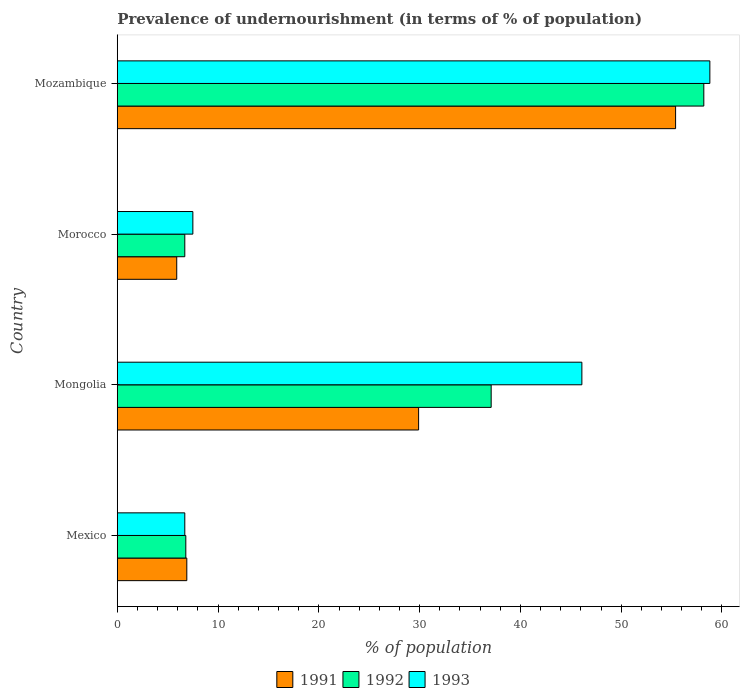How many different coloured bars are there?
Give a very brief answer. 3. Are the number of bars per tick equal to the number of legend labels?
Provide a succinct answer. Yes. How many bars are there on the 4th tick from the bottom?
Give a very brief answer. 3. What is the label of the 1st group of bars from the top?
Ensure brevity in your answer.  Mozambique. In how many cases, is the number of bars for a given country not equal to the number of legend labels?
Your answer should be compact. 0. What is the percentage of undernourished population in 1993 in Mozambique?
Offer a very short reply. 58.8. Across all countries, what is the maximum percentage of undernourished population in 1991?
Provide a short and direct response. 55.4. Across all countries, what is the minimum percentage of undernourished population in 1993?
Provide a succinct answer. 6.7. In which country was the percentage of undernourished population in 1992 maximum?
Offer a terse response. Mozambique. In which country was the percentage of undernourished population in 1992 minimum?
Make the answer very short. Morocco. What is the total percentage of undernourished population in 1992 in the graph?
Keep it short and to the point. 108.8. What is the difference between the percentage of undernourished population in 1993 in Mexico and that in Mongolia?
Offer a terse response. -39.4. What is the difference between the percentage of undernourished population in 1991 in Morocco and the percentage of undernourished population in 1993 in Mozambique?
Your response must be concise. -52.9. What is the average percentage of undernourished population in 1993 per country?
Provide a short and direct response. 29.77. What is the difference between the percentage of undernourished population in 1991 and percentage of undernourished population in 1992 in Mexico?
Your answer should be compact. 0.1. In how many countries, is the percentage of undernourished population in 1992 greater than 54 %?
Your answer should be compact. 1. What is the ratio of the percentage of undernourished population in 1991 in Mongolia to that in Morocco?
Ensure brevity in your answer.  5.07. Is the percentage of undernourished population in 1993 in Mongolia less than that in Morocco?
Give a very brief answer. No. Is the difference between the percentage of undernourished population in 1991 in Morocco and Mozambique greater than the difference between the percentage of undernourished population in 1992 in Morocco and Mozambique?
Ensure brevity in your answer.  Yes. What is the difference between the highest and the second highest percentage of undernourished population in 1992?
Offer a terse response. 21.1. What is the difference between the highest and the lowest percentage of undernourished population in 1993?
Offer a terse response. 52.1. Is the sum of the percentage of undernourished population in 1993 in Mexico and Mongolia greater than the maximum percentage of undernourished population in 1992 across all countries?
Ensure brevity in your answer.  No. What does the 3rd bar from the top in Mexico represents?
Offer a very short reply. 1991. How many bars are there?
Make the answer very short. 12. Are all the bars in the graph horizontal?
Keep it short and to the point. Yes. How many countries are there in the graph?
Give a very brief answer. 4. What is the difference between two consecutive major ticks on the X-axis?
Give a very brief answer. 10. Are the values on the major ticks of X-axis written in scientific E-notation?
Keep it short and to the point. No. What is the title of the graph?
Keep it short and to the point. Prevalence of undernourishment (in terms of % of population). Does "2000" appear as one of the legend labels in the graph?
Provide a succinct answer. No. What is the label or title of the X-axis?
Offer a terse response. % of population. What is the label or title of the Y-axis?
Your answer should be compact. Country. What is the % of population in 1991 in Mexico?
Your answer should be very brief. 6.9. What is the % of population in 1992 in Mexico?
Keep it short and to the point. 6.8. What is the % of population in 1991 in Mongolia?
Offer a very short reply. 29.9. What is the % of population of 1992 in Mongolia?
Offer a very short reply. 37.1. What is the % of population in 1993 in Mongolia?
Provide a short and direct response. 46.1. What is the % of population in 1991 in Morocco?
Offer a very short reply. 5.9. What is the % of population in 1991 in Mozambique?
Make the answer very short. 55.4. What is the % of population of 1992 in Mozambique?
Keep it short and to the point. 58.2. What is the % of population in 1993 in Mozambique?
Your answer should be compact. 58.8. Across all countries, what is the maximum % of population in 1991?
Ensure brevity in your answer.  55.4. Across all countries, what is the maximum % of population of 1992?
Give a very brief answer. 58.2. Across all countries, what is the maximum % of population in 1993?
Your answer should be compact. 58.8. What is the total % of population in 1991 in the graph?
Your answer should be compact. 98.1. What is the total % of population in 1992 in the graph?
Ensure brevity in your answer.  108.8. What is the total % of population in 1993 in the graph?
Offer a very short reply. 119.1. What is the difference between the % of population in 1991 in Mexico and that in Mongolia?
Offer a terse response. -23. What is the difference between the % of population in 1992 in Mexico and that in Mongolia?
Your answer should be compact. -30.3. What is the difference between the % of population of 1993 in Mexico and that in Mongolia?
Keep it short and to the point. -39.4. What is the difference between the % of population of 1991 in Mexico and that in Morocco?
Your answer should be very brief. 1. What is the difference between the % of population of 1993 in Mexico and that in Morocco?
Your answer should be compact. -0.8. What is the difference between the % of population in 1991 in Mexico and that in Mozambique?
Provide a short and direct response. -48.5. What is the difference between the % of population in 1992 in Mexico and that in Mozambique?
Ensure brevity in your answer.  -51.4. What is the difference between the % of population of 1993 in Mexico and that in Mozambique?
Make the answer very short. -52.1. What is the difference between the % of population in 1992 in Mongolia and that in Morocco?
Offer a very short reply. 30.4. What is the difference between the % of population of 1993 in Mongolia and that in Morocco?
Your answer should be compact. 38.6. What is the difference between the % of population of 1991 in Mongolia and that in Mozambique?
Your response must be concise. -25.5. What is the difference between the % of population of 1992 in Mongolia and that in Mozambique?
Offer a terse response. -21.1. What is the difference between the % of population in 1993 in Mongolia and that in Mozambique?
Ensure brevity in your answer.  -12.7. What is the difference between the % of population in 1991 in Morocco and that in Mozambique?
Keep it short and to the point. -49.5. What is the difference between the % of population of 1992 in Morocco and that in Mozambique?
Your response must be concise. -51.5. What is the difference between the % of population of 1993 in Morocco and that in Mozambique?
Your answer should be very brief. -51.3. What is the difference between the % of population of 1991 in Mexico and the % of population of 1992 in Mongolia?
Offer a very short reply. -30.2. What is the difference between the % of population in 1991 in Mexico and the % of population in 1993 in Mongolia?
Offer a terse response. -39.2. What is the difference between the % of population in 1992 in Mexico and the % of population in 1993 in Mongolia?
Provide a short and direct response. -39.3. What is the difference between the % of population in 1991 in Mexico and the % of population in 1993 in Morocco?
Provide a succinct answer. -0.6. What is the difference between the % of population in 1991 in Mexico and the % of population in 1992 in Mozambique?
Provide a short and direct response. -51.3. What is the difference between the % of population in 1991 in Mexico and the % of population in 1993 in Mozambique?
Your answer should be very brief. -51.9. What is the difference between the % of population in 1992 in Mexico and the % of population in 1993 in Mozambique?
Your answer should be compact. -52. What is the difference between the % of population in 1991 in Mongolia and the % of population in 1992 in Morocco?
Your answer should be very brief. 23.2. What is the difference between the % of population of 1991 in Mongolia and the % of population of 1993 in Morocco?
Offer a terse response. 22.4. What is the difference between the % of population of 1992 in Mongolia and the % of population of 1993 in Morocco?
Your answer should be compact. 29.6. What is the difference between the % of population of 1991 in Mongolia and the % of population of 1992 in Mozambique?
Ensure brevity in your answer.  -28.3. What is the difference between the % of population of 1991 in Mongolia and the % of population of 1993 in Mozambique?
Your response must be concise. -28.9. What is the difference between the % of population of 1992 in Mongolia and the % of population of 1993 in Mozambique?
Give a very brief answer. -21.7. What is the difference between the % of population of 1991 in Morocco and the % of population of 1992 in Mozambique?
Your answer should be compact. -52.3. What is the difference between the % of population in 1991 in Morocco and the % of population in 1993 in Mozambique?
Ensure brevity in your answer.  -52.9. What is the difference between the % of population in 1992 in Morocco and the % of population in 1993 in Mozambique?
Provide a succinct answer. -52.1. What is the average % of population in 1991 per country?
Your response must be concise. 24.52. What is the average % of population in 1992 per country?
Your response must be concise. 27.2. What is the average % of population in 1993 per country?
Offer a terse response. 29.77. What is the difference between the % of population of 1991 and % of population of 1992 in Mongolia?
Ensure brevity in your answer.  -7.2. What is the difference between the % of population in 1991 and % of population in 1993 in Mongolia?
Your response must be concise. -16.2. What is the difference between the % of population in 1992 and % of population in 1993 in Mongolia?
Provide a succinct answer. -9. What is the difference between the % of population in 1991 and % of population in 1992 in Morocco?
Ensure brevity in your answer.  -0.8. What is the difference between the % of population in 1992 and % of population in 1993 in Morocco?
Offer a very short reply. -0.8. What is the difference between the % of population in 1991 and % of population in 1992 in Mozambique?
Ensure brevity in your answer.  -2.8. What is the difference between the % of population in 1991 and % of population in 1993 in Mozambique?
Offer a terse response. -3.4. What is the difference between the % of population in 1992 and % of population in 1993 in Mozambique?
Give a very brief answer. -0.6. What is the ratio of the % of population in 1991 in Mexico to that in Mongolia?
Provide a short and direct response. 0.23. What is the ratio of the % of population in 1992 in Mexico to that in Mongolia?
Ensure brevity in your answer.  0.18. What is the ratio of the % of population in 1993 in Mexico to that in Mongolia?
Offer a very short reply. 0.15. What is the ratio of the % of population of 1991 in Mexico to that in Morocco?
Give a very brief answer. 1.17. What is the ratio of the % of population in 1992 in Mexico to that in Morocco?
Make the answer very short. 1.01. What is the ratio of the % of population in 1993 in Mexico to that in Morocco?
Provide a short and direct response. 0.89. What is the ratio of the % of population of 1991 in Mexico to that in Mozambique?
Your answer should be compact. 0.12. What is the ratio of the % of population of 1992 in Mexico to that in Mozambique?
Provide a succinct answer. 0.12. What is the ratio of the % of population of 1993 in Mexico to that in Mozambique?
Offer a very short reply. 0.11. What is the ratio of the % of population in 1991 in Mongolia to that in Morocco?
Keep it short and to the point. 5.07. What is the ratio of the % of population in 1992 in Mongolia to that in Morocco?
Your answer should be very brief. 5.54. What is the ratio of the % of population of 1993 in Mongolia to that in Morocco?
Provide a succinct answer. 6.15. What is the ratio of the % of population in 1991 in Mongolia to that in Mozambique?
Your response must be concise. 0.54. What is the ratio of the % of population of 1992 in Mongolia to that in Mozambique?
Offer a very short reply. 0.64. What is the ratio of the % of population in 1993 in Mongolia to that in Mozambique?
Provide a short and direct response. 0.78. What is the ratio of the % of population of 1991 in Morocco to that in Mozambique?
Keep it short and to the point. 0.11. What is the ratio of the % of population of 1992 in Morocco to that in Mozambique?
Offer a terse response. 0.12. What is the ratio of the % of population in 1993 in Morocco to that in Mozambique?
Offer a very short reply. 0.13. What is the difference between the highest and the second highest % of population in 1991?
Make the answer very short. 25.5. What is the difference between the highest and the second highest % of population of 1992?
Keep it short and to the point. 21.1. What is the difference between the highest and the lowest % of population in 1991?
Provide a short and direct response. 49.5. What is the difference between the highest and the lowest % of population of 1992?
Keep it short and to the point. 51.5. What is the difference between the highest and the lowest % of population of 1993?
Give a very brief answer. 52.1. 